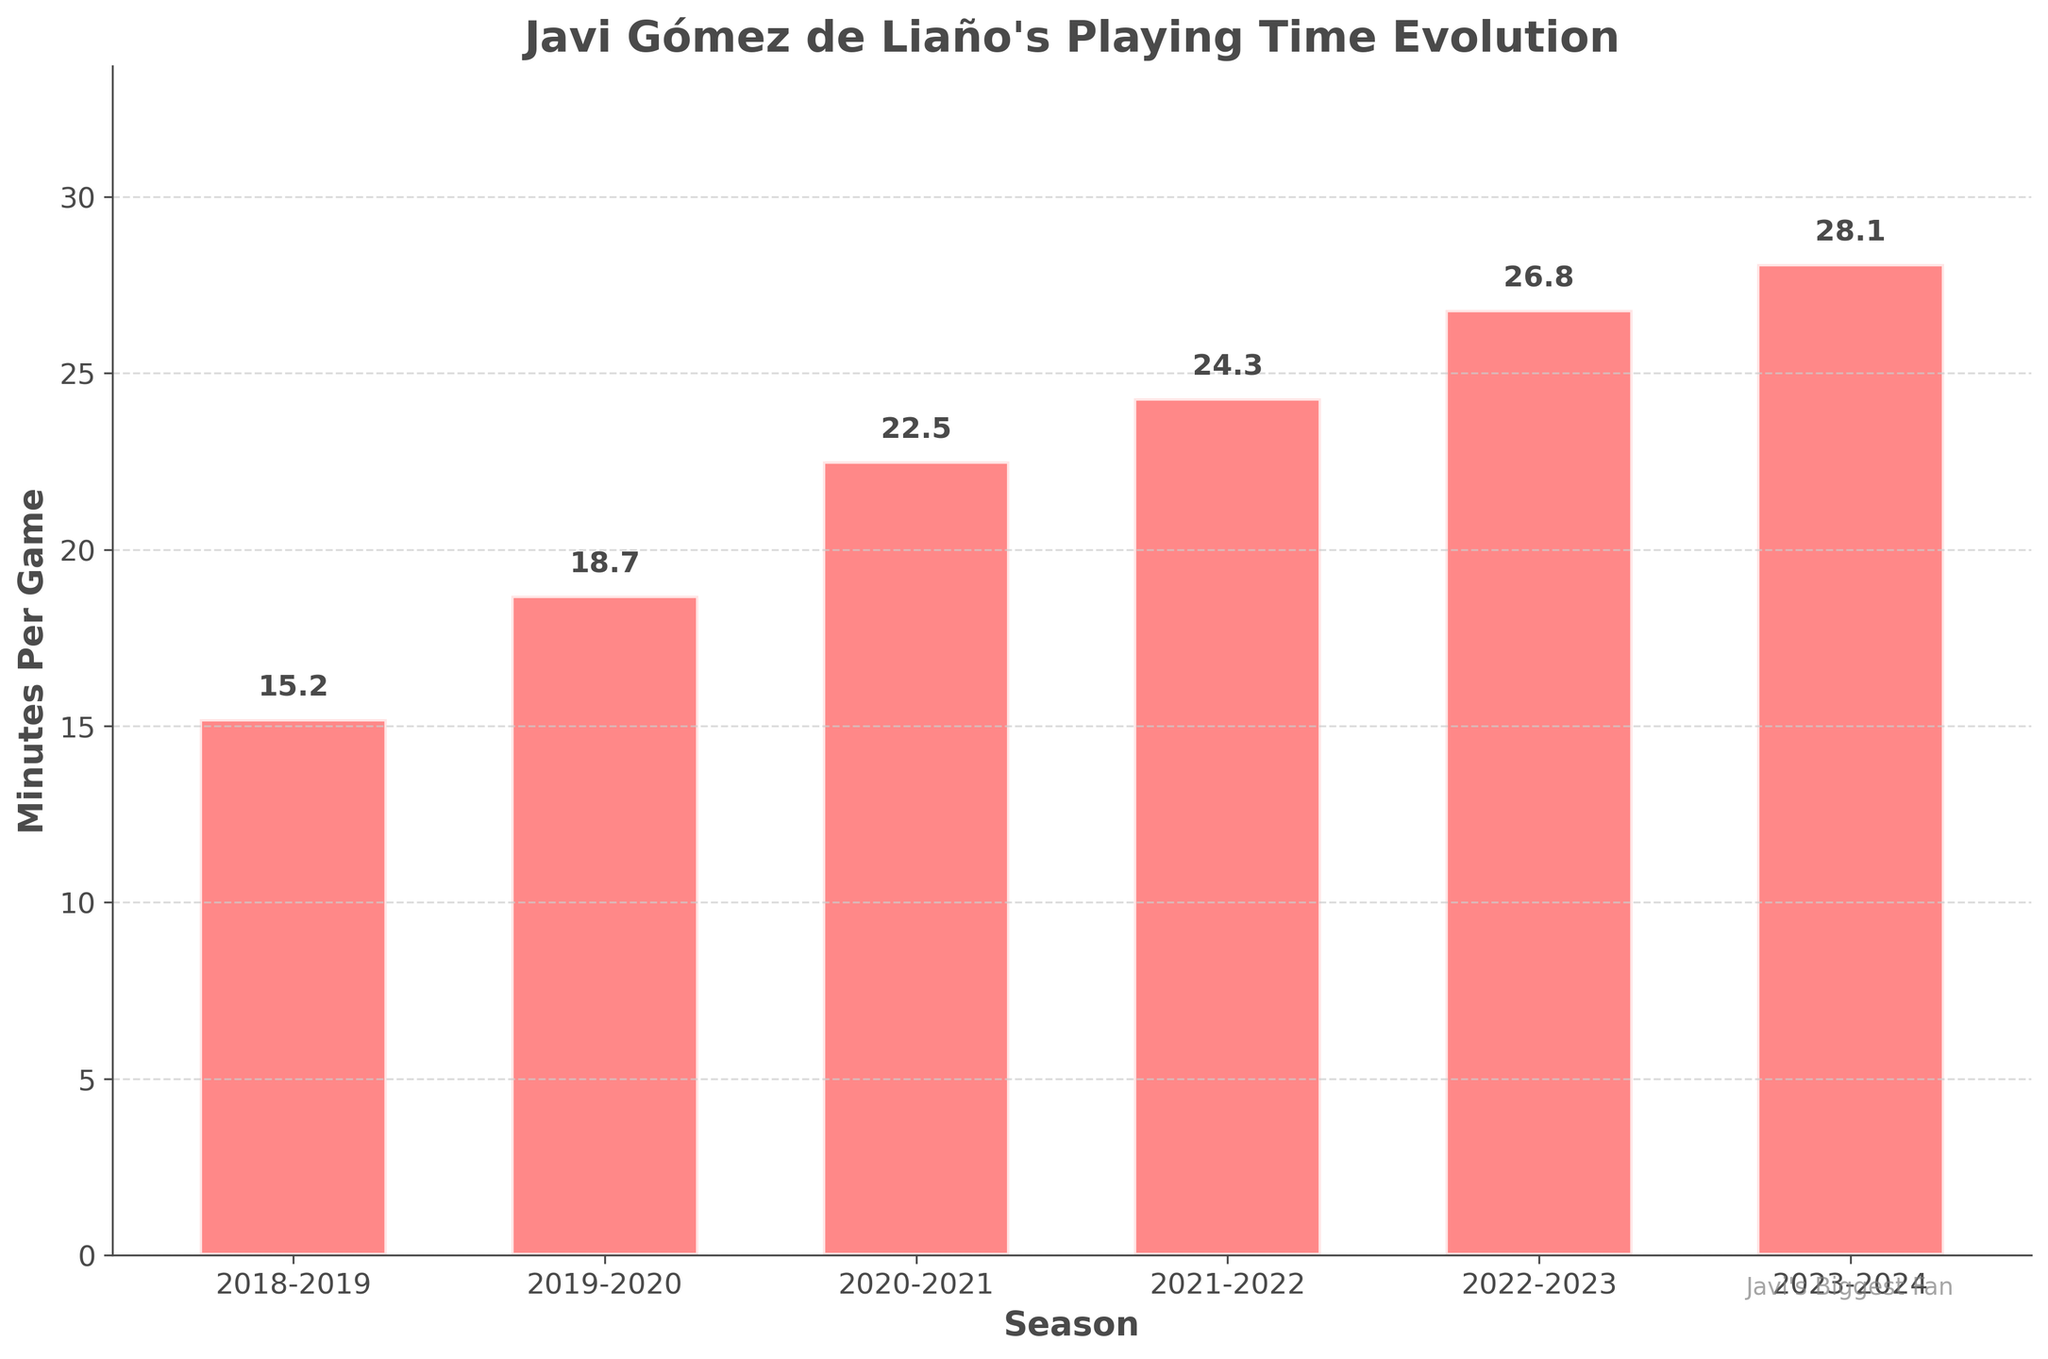Which season had the highest average minutes per game? By observing the height of the bars, the tallest bar represents the highest average minutes per game. The tallest bar corresponds to the 2023-2024 season.
Answer: 2023-2024 What's the difference in average minutes per game between the 2018-2019 and 2023-2024 seasons? Subtract the average minutes per game of the 2018-2019 season from the 2023-2024 season. From the bar chart, the values are 28.1 for 2023-2024 and 15.2 for 2018-2019. Thus, 28.1 - 15.2 = 12.9.
Answer: 12.9 What is the average playing time across all seasons shown? To find the average, sum the average minutes per game of all seasons and divide by the number of seasons. The values are 15.2, 18.7, 22.5, 24.3, 26.8, and 28.1. The sum is 135.6. There are 6 seasons, so the average is 135.6 / 6 = 22.6.
Answer: 22.6 How much did Javi's average minutes per game increase from the 2019-2020 to the 2020-2021 season? Subtract the average minutes per game of the 2019-2020 season from the 2020-2021 season. From the bar chart, the values are 22.5 for 2020-2021 and 18.7 for 2019-2020. Thus, 22.5 - 18.7 = 3.8.
Answer: 3.8 In which season did Javi Gómez de Liaño see the steepest increase in average minutes per game compared to the previous season? Calculate the increase in average minutes per game for each season compared to the previous season. The increases are 3.5 (2018-2019 to 2019-2020), 3.8 (2019-2020 to 2020-2021), 1.8 (2020-2021 to 2021-2022), 2.5 (2021-2022 to 2022-2023), and 1.3 (2022-2023 to 2023-2024), so the steepest increase was from 2019-2020 to 2020-2021.
Answer: 2019-2020 to 2020-2021 How many seasons had an average playing time of over 20 minutes per game? Count the bars that represent average minutes per game over 20. From the bar chart, the seasons are 2020-2021, 2021-2022, 2022-2023, and 2023-2024. There are 4 such seasons.
Answer: 4 Was there any season where the average minutes per game decreased compared to the previous season? Check each pair of consecutive seasons to see if the average minutes per game decreased. By observing the chart, the average minutes per game consistently increased every season.
Answer: No What's the percentage increase in average minutes per game from the 2018-2019 season to the 2023-2024 season? Calculate the percentage increase: ((New Value - Old Value) / Old Value) * 100. From the bar chart, the values are 28.1 for 2023-2024 and 15.2 for 2018-2019. So, ((28.1 - 15.2) / 15.2) * 100 ≈ 84.9%.
Answer: 84.9% Is there a visible grid on the graph, and if so, which axis is it applied to? Observe the visual layout of the graph. The grid lines are visible on the y-axis (vertical axis).
Answer: Yes, y-axis What is the annotation at the bottom right of the figure? Read the text present at the bottom right of the figure. It states "Javi's Biggest Fan."
Answer: Javi's Biggest Fan 